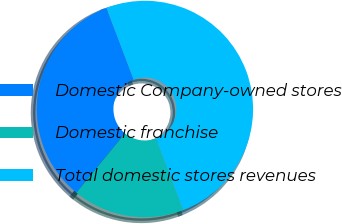Convert chart to OTSL. <chart><loc_0><loc_0><loc_500><loc_500><pie_chart><fcel>Domestic Company-owned stores<fcel>Domestic franchise<fcel>Total domestic stores revenues<nl><fcel>33.3%<fcel>16.7%<fcel>50.0%<nl></chart> 